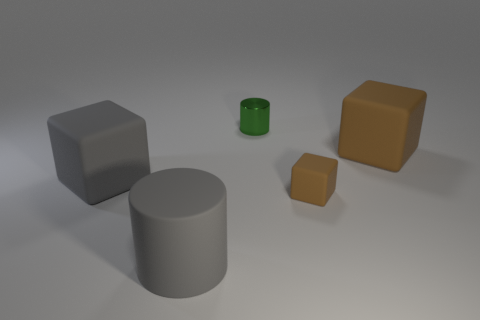What material is the large thing that is the same shape as the tiny shiny thing?
Provide a succinct answer. Rubber. Is there any other thing that is the same material as the green thing?
Keep it short and to the point. No. Are there any small objects on the right side of the tiny brown matte thing?
Offer a very short reply. No. What number of big yellow rubber objects are there?
Offer a terse response. 0. There is a brown object that is in front of the big brown matte object; how many large rubber blocks are to the left of it?
Offer a very short reply. 1. Is the color of the small shiny cylinder the same as the tiny matte block that is in front of the green cylinder?
Your answer should be compact. No. What number of tiny matte objects have the same shape as the green metal thing?
Your answer should be compact. 0. What material is the cylinder to the left of the tiny green cylinder?
Your response must be concise. Rubber. Do the big matte thing that is right of the green metallic cylinder and the tiny brown rubber object have the same shape?
Make the answer very short. Yes. Are there any green objects of the same size as the rubber cylinder?
Offer a terse response. No. 